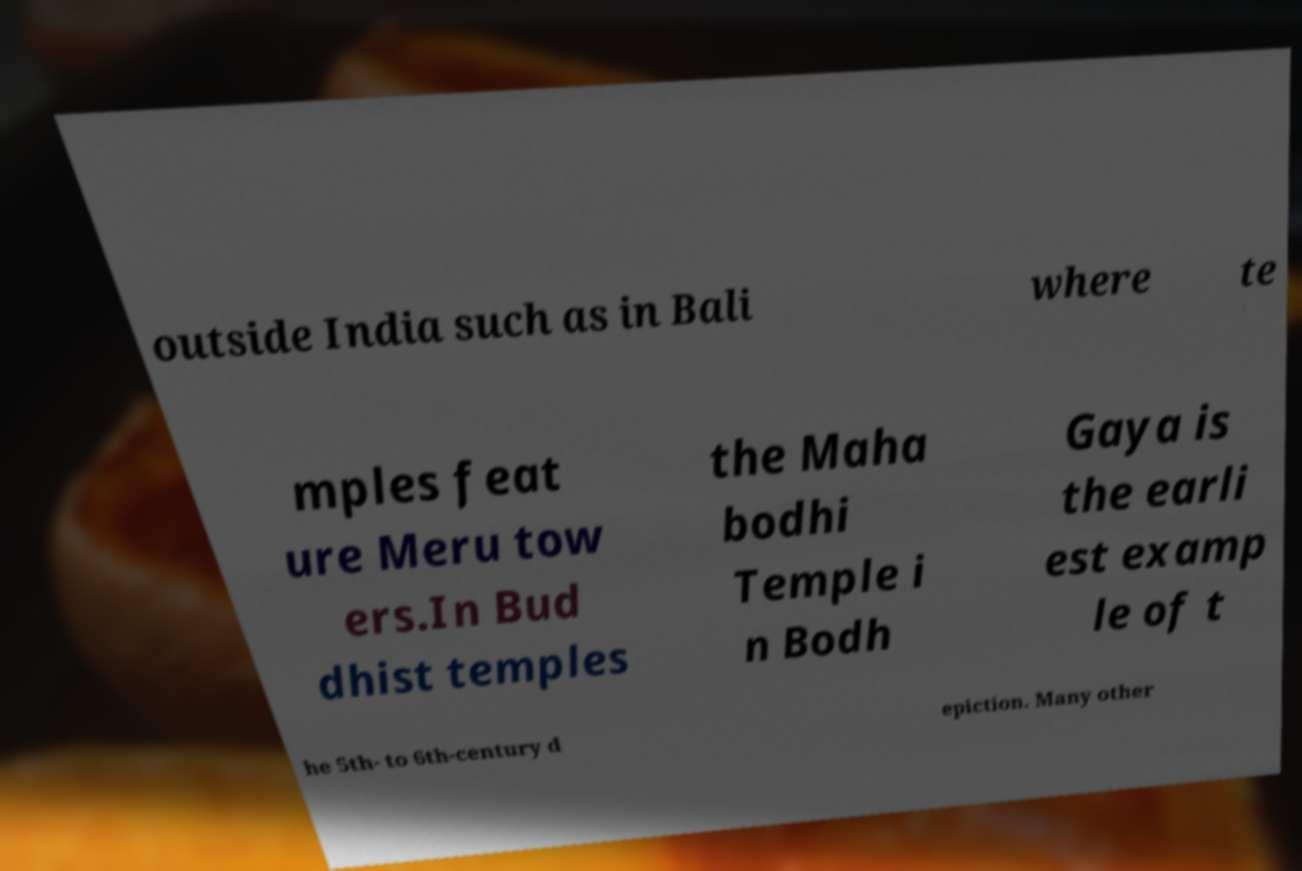Can you read and provide the text displayed in the image?This photo seems to have some interesting text. Can you extract and type it out for me? outside India such as in Bali where te mples feat ure Meru tow ers.In Bud dhist temples the Maha bodhi Temple i n Bodh Gaya is the earli est examp le of t he 5th- to 6th-century d epiction. Many other 